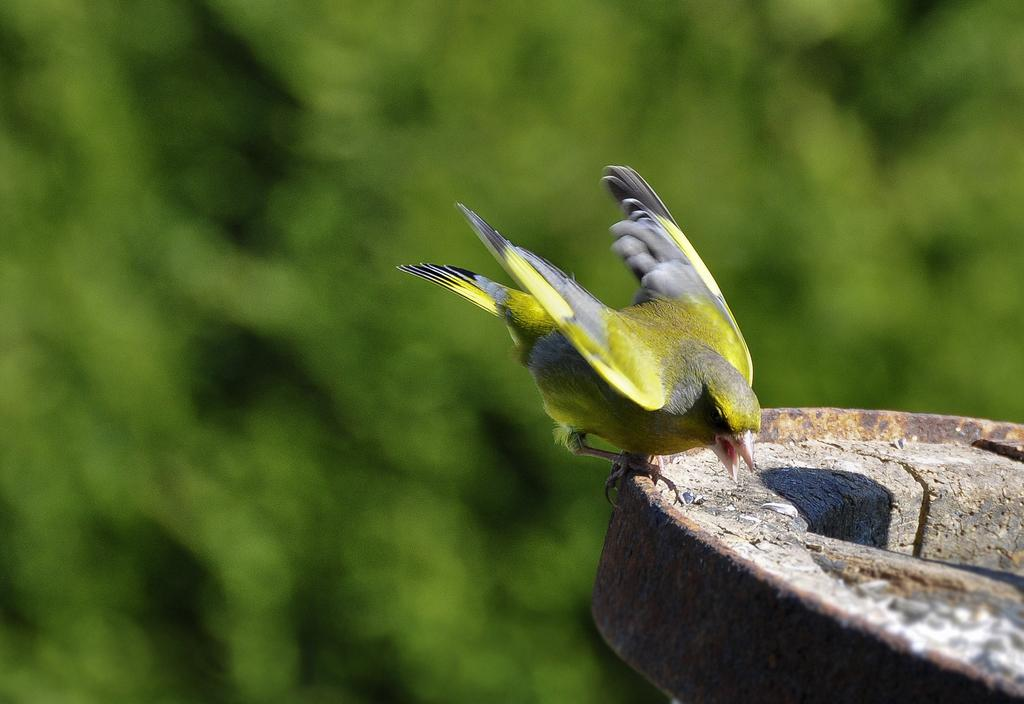What type of animal is in the image? There is a bird in the image. Where is the bird located? The bird is on an object. Can you describe the background of the image? The background of the image is blurry. What type of trade is happening between the man and the bird in the image? There is no man present in the image, and therefore no trade can be observed. 